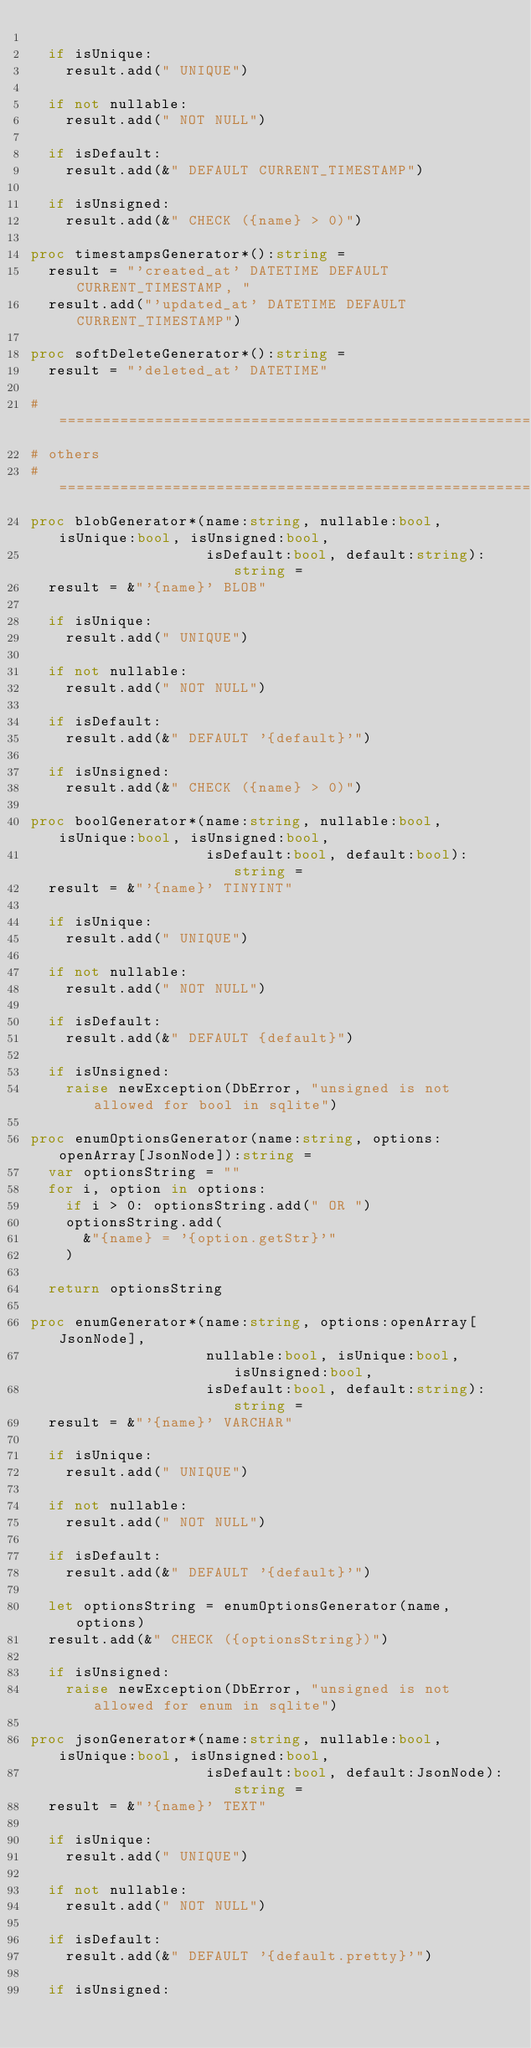<code> <loc_0><loc_0><loc_500><loc_500><_Nim_>
  if isUnique:
    result.add(" UNIQUE")

  if not nullable:
    result.add(" NOT NULL")

  if isDefault:
    result.add(&" DEFAULT CURRENT_TIMESTAMP")

  if isUnsigned:
    result.add(&" CHECK ({name} > 0)")

proc timestampsGenerator*():string =
  result = "'created_at' DATETIME DEFAULT CURRENT_TIMESTAMP, "
  result.add("'updated_at' DATETIME DEFAULT CURRENT_TIMESTAMP")

proc softDeleteGenerator*():string =
  result = "'deleted_at' DATETIME"

# =============================================================================
# others
# =============================================================================
proc blobGenerator*(name:string, nullable:bool, isUnique:bool, isUnsigned:bool,
                    isDefault:bool, default:string):string =
  result = &"'{name}' BLOB"

  if isUnique:
    result.add(" UNIQUE")

  if not nullable:
    result.add(" NOT NULL")

  if isDefault:
    result.add(&" DEFAULT '{default}'")

  if isUnsigned:
    result.add(&" CHECK ({name} > 0)")

proc boolGenerator*(name:string, nullable:bool, isUnique:bool, isUnsigned:bool,
                    isDefault:bool, default:bool):string =
  result = &"'{name}' TINYINT"

  if isUnique:
    result.add(" UNIQUE")

  if not nullable:
    result.add(" NOT NULL")

  if isDefault:
    result.add(&" DEFAULT {default}")

  if isUnsigned:
    raise newException(DbError, "unsigned is not allowed for bool in sqlite")

proc enumOptionsGenerator(name:string, options:openArray[JsonNode]):string =
  var optionsString = ""
  for i, option in options:
    if i > 0: optionsString.add(" OR ")
    optionsString.add(
      &"{name} = '{option.getStr}'"
    )

  return optionsString

proc enumGenerator*(name:string, options:openArray[JsonNode],
                    nullable:bool, isUnique:bool, isUnsigned:bool,
                    isDefault:bool, default:string):string =
  result = &"'{name}' VARCHAR"

  if isUnique:
    result.add(" UNIQUE")

  if not nullable:
    result.add(" NOT NULL")

  if isDefault:
    result.add(&" DEFAULT '{default}'")

  let optionsString = enumOptionsGenerator(name, options)
  result.add(&" CHECK ({optionsString})")

  if isUnsigned:
    raise newException(DbError, "unsigned is not allowed for enum in sqlite")

proc jsonGenerator*(name:string, nullable:bool, isUnique:bool, isUnsigned:bool,
                    isDefault:bool, default:JsonNode):string =
  result = &"'{name}' TEXT"

  if isUnique:
    result.add(" UNIQUE")

  if not nullable:
    result.add(" NOT NULL")

  if isDefault:
    result.add(&" DEFAULT '{default.pretty}'")

  if isUnsigned:</code> 